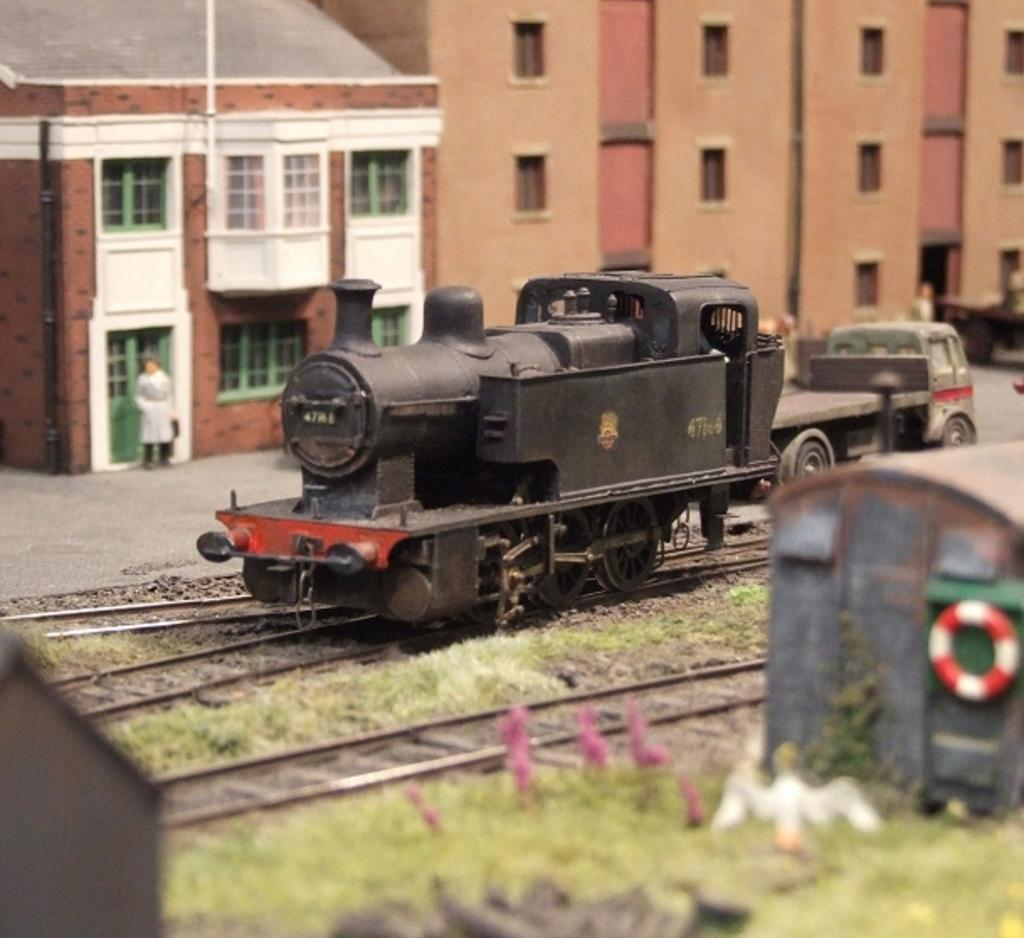What type of toys are present in the image? There are toys of trains in the image. What other objects can be seen in the image? There is a vehicle, railway tracks, a doll, and buildings in the image. What is the surrounding environment like in the image? Grass is present in the image. Is there any infrastructure related to the trains in the image? Yes, there is a tube to the train in the image. What type of drug is the writer using in the image? There is no writer or drug present in the image. How much dirt can be seen on the doll in the image? There is no dirt visible on the doll in the image. 